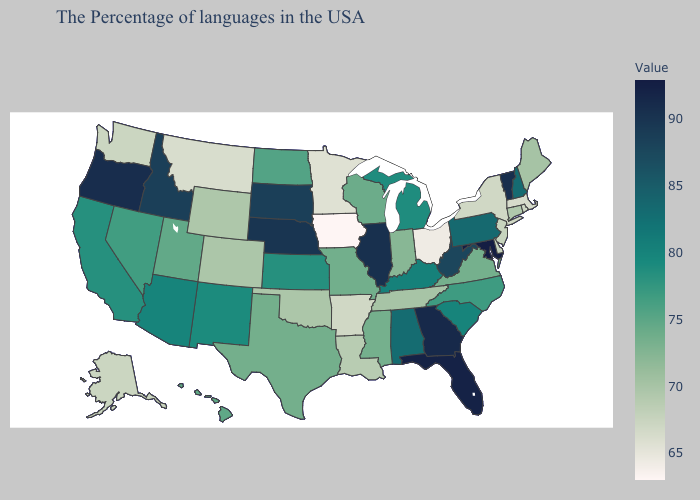Which states have the highest value in the USA?
Concise answer only. Maryland. Is the legend a continuous bar?
Keep it brief. Yes. Which states hav the highest value in the Northeast?
Be succinct. Vermont. Is the legend a continuous bar?
Short answer required. Yes. Which states have the lowest value in the USA?
Quick response, please. Iowa. 